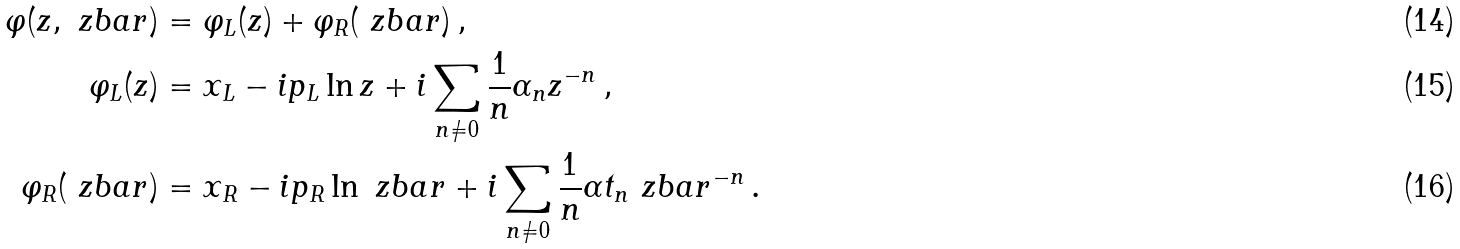Convert formula to latex. <formula><loc_0><loc_0><loc_500><loc_500>\varphi ( z , \ z b a r ) & = \varphi _ { L } ( z ) + \varphi _ { R } ( \ z b a r ) \, , \\ \varphi _ { L } ( z ) & = x _ { L } - i p _ { L } \ln z + i \sum _ { n \ne 0 } \frac { 1 } { n } \alpha _ { n } z ^ { - n } \, , \\ \varphi _ { R } ( \ z b a r ) & = x _ { R } - i p _ { R } \ln \ z b a r + i \sum _ { n \ne 0 } \frac { 1 } { n } \alpha t _ { n } \ z b a r ^ { - n } \, .</formula> 